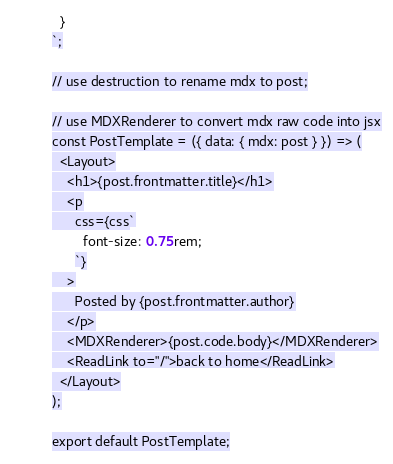<code> <loc_0><loc_0><loc_500><loc_500><_JavaScript_>  }
`;

// use destruction to rename mdx to post;

// use MDXRenderer to convert mdx raw code into jsx
const PostTemplate = ({ data: { mdx: post } }) => (
  <Layout>
    <h1>{post.frontmatter.title}</h1>
    <p
      css={css`
        font-size: 0.75rem;
      `}
    >
      Posted by {post.frontmatter.author}
    </p>
    <MDXRenderer>{post.code.body}</MDXRenderer>
    <ReadLink to="/">back to home</ReadLink>
  </Layout>
);

export default PostTemplate;
</code> 